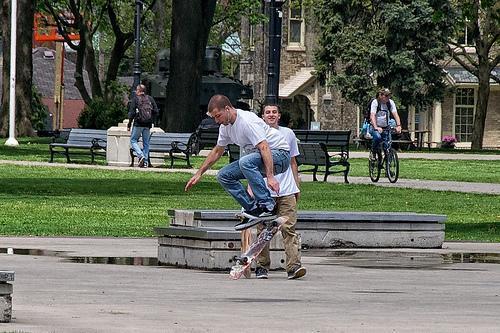How many people are in the picture?
Give a very brief answer. 4. 